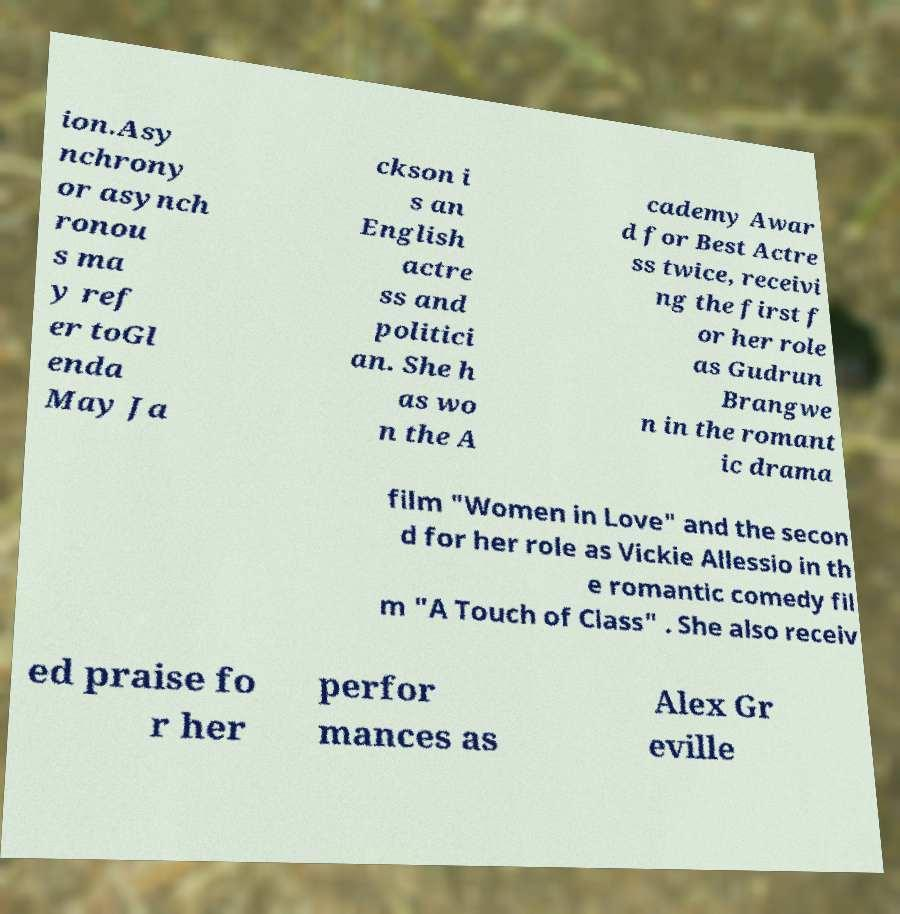Could you extract and type out the text from this image? ion.Asy nchrony or asynch ronou s ma y ref er toGl enda May Ja ckson i s an English actre ss and politici an. She h as wo n the A cademy Awar d for Best Actre ss twice, receivi ng the first f or her role as Gudrun Brangwe n in the romant ic drama film "Women in Love" and the secon d for her role as Vickie Allessio in th e romantic comedy fil m "A Touch of Class" . She also receiv ed praise fo r her perfor mances as Alex Gr eville 